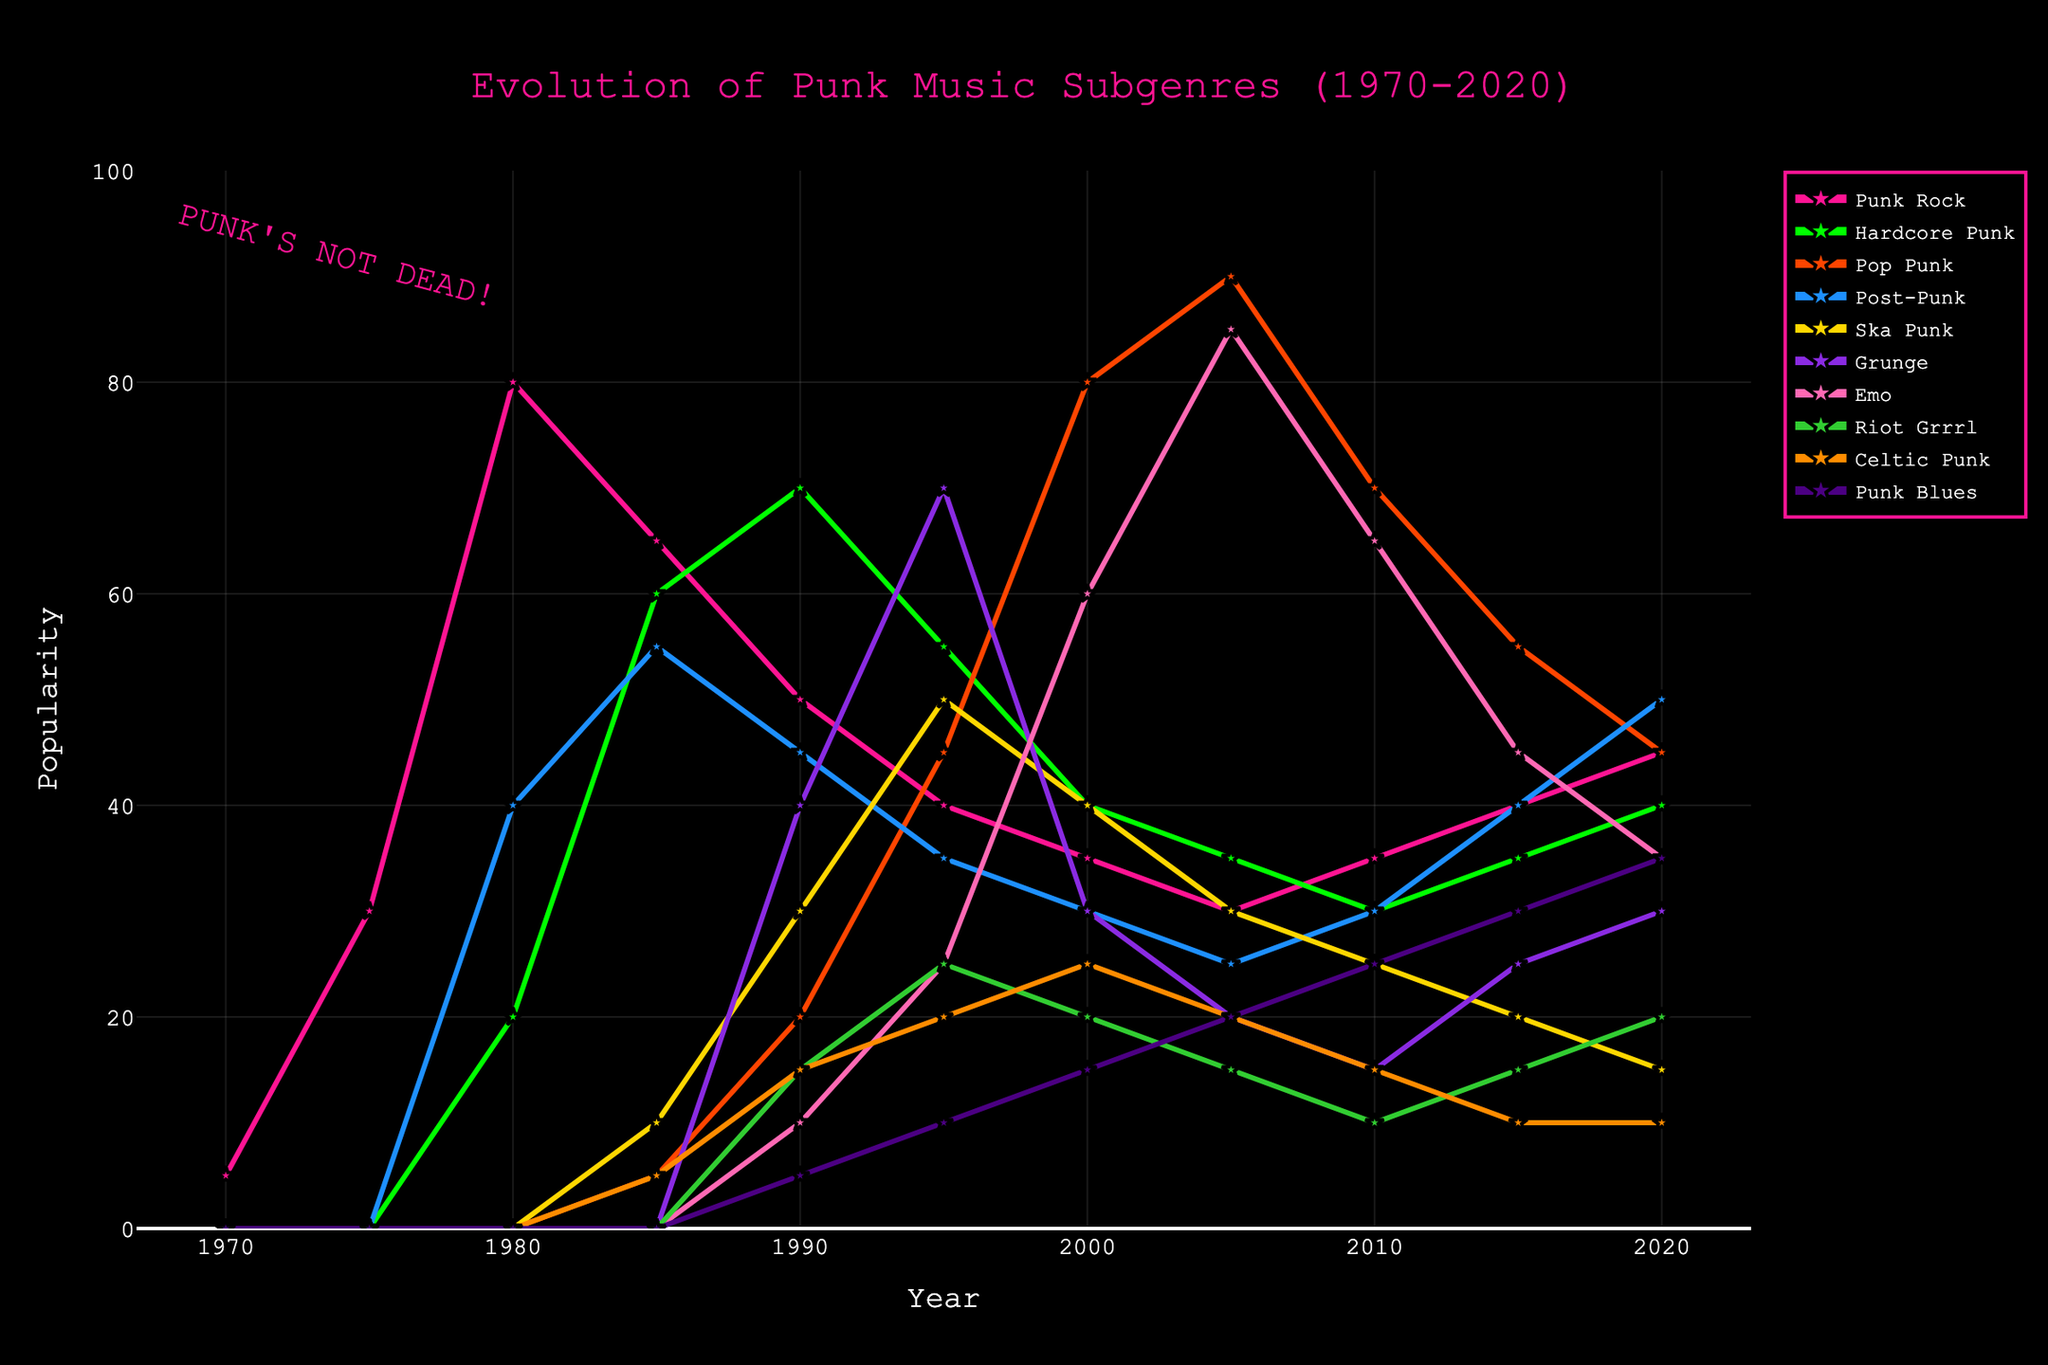What subgenre was the most popular in 1980? To find the most popular subgenre in 1980, we look for the highest value in that year. Punk Rock has the highest value at 80.
Answer: Punk Rock How did the popularity of Hardcore Punk change from 1985 to 1995? Compare the values of Hardcore Punk in 1985 and 1995. It started at 60 in 1985 and decreased to 55 in 1995.
Answer: Decreased Which subgenres peaked in 2005? Identify the highest values for each subgenre and check their corresponding years. Pop Punk and Emo both peak in 2005 with values of 90 and 85, respectively.
Answer: Pop Punk, Emo What was the difference in popularity between Ska Punk and Celtic Punk in 2000? Look at the values for Ska Punk and Celtic Punk in the year 2000, which are 40 and 25 respectively. Calculate the difference: 40 - 25 = 15.
Answer: 15 What is the trend of Grunge from 1990 to 2020? Observe the values of Grunge from 1990 to 2020. It peaks in 1995 at 70, then generally declines with small fluctuations.
Answer: Declining In which year did Post-Punk have the same popularity as Punk Rock? Check the graph where the value for Post-Punk matches Punk Rock. 2010 shows Post-Punk and Punk Rock both at 30.
Answer: 2010 How did Riot Grrrl's popularity change between 1990 and 1995? Compare the values for Riot Grrrl in 1990 and 1995. It increased from 15 to 25.
Answer: Increased Which subgenre experienced the most consistent growth from 2010 to 2020? Look for a subgenre that shows a steady increase from 2010 to 2020. Post-Punk shows a consistent rise from 30 to 50.
Answer: Post-Punk Compare the popularity of Pop Punk and Emo in 2005. Which was more popular? Look at the values for Pop Punk and Emo in 2005. Pop Punk is at 90, while Emo is at 85. Pop Punk is more popular.
Answer: Pop Punk 